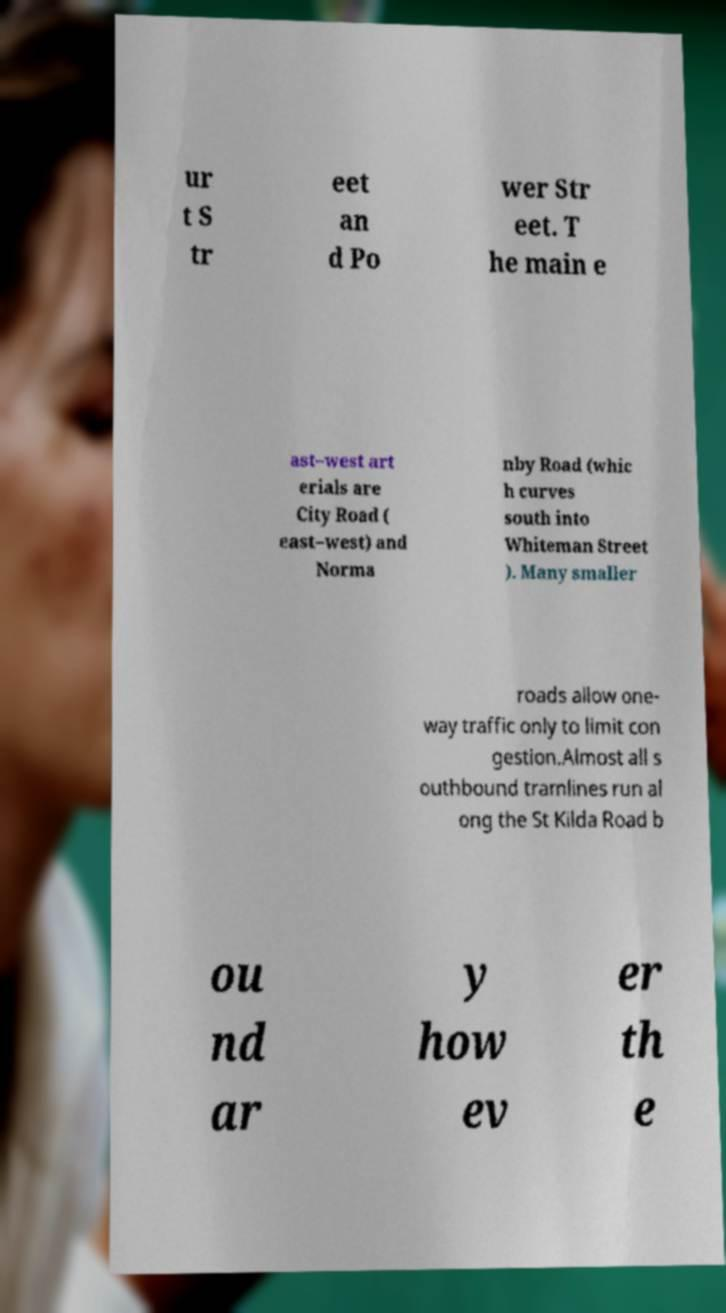Can you accurately transcribe the text from the provided image for me? ur t S tr eet an d Po wer Str eet. T he main e ast–west art erials are City Road ( east–west) and Norma nby Road (whic h curves south into Whiteman Street ). Many smaller roads allow one- way traffic only to limit con gestion.Almost all s outhbound tramlines run al ong the St Kilda Road b ou nd ar y how ev er th e 